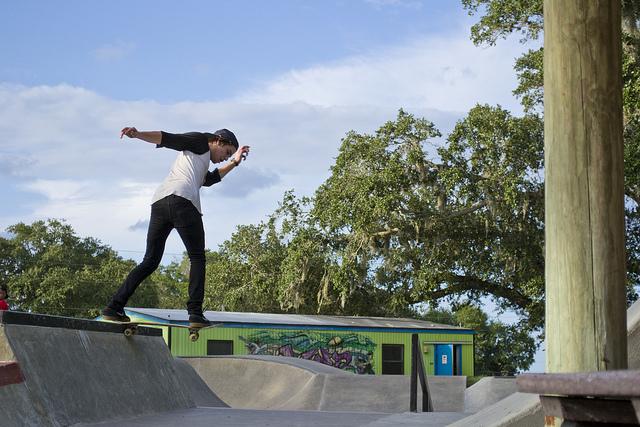Is the border going to hit the pole?
Answer briefly. No. Is anything outfitted with nuclear propulsion in this image?
Answer briefly. No. What color is the door on the trailer?
Write a very short answer. Blue. 